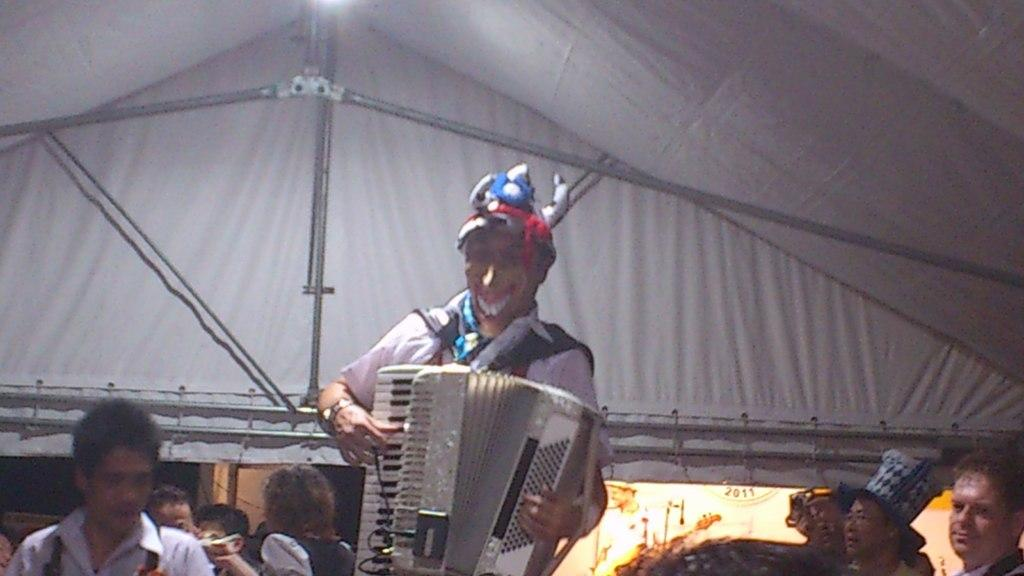What is the main subject of the image? There is a person in the image. What is the person doing in the image? The person is playing a musical instrument. Are there any other people visible in the image? Yes, there are persons in the bottom left and bottom right of the image. What type of grain can be seen growing in the image? There is no grain visible in the image; it features a person playing a musical instrument and other people in the bottom left and bottom right. How many bushes are present in the image? There are no bushes present in the image. 